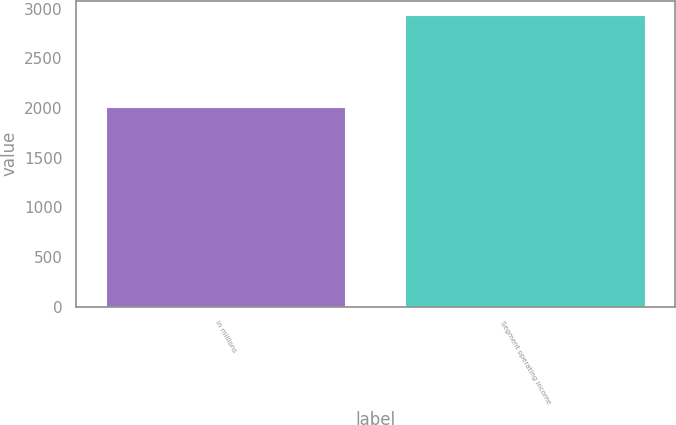<chart> <loc_0><loc_0><loc_500><loc_500><bar_chart><fcel>in millions<fcel>Segment operating income<nl><fcel>2016<fcel>2935<nl></chart> 